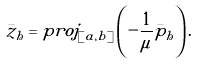Convert formula to latex. <formula><loc_0><loc_0><loc_500><loc_500>\bar { z } _ { h } = p r o j _ { [ a , b ] } \left ( - \frac { 1 } { \mu } \bar { p } _ { h } \right ) .</formula> 